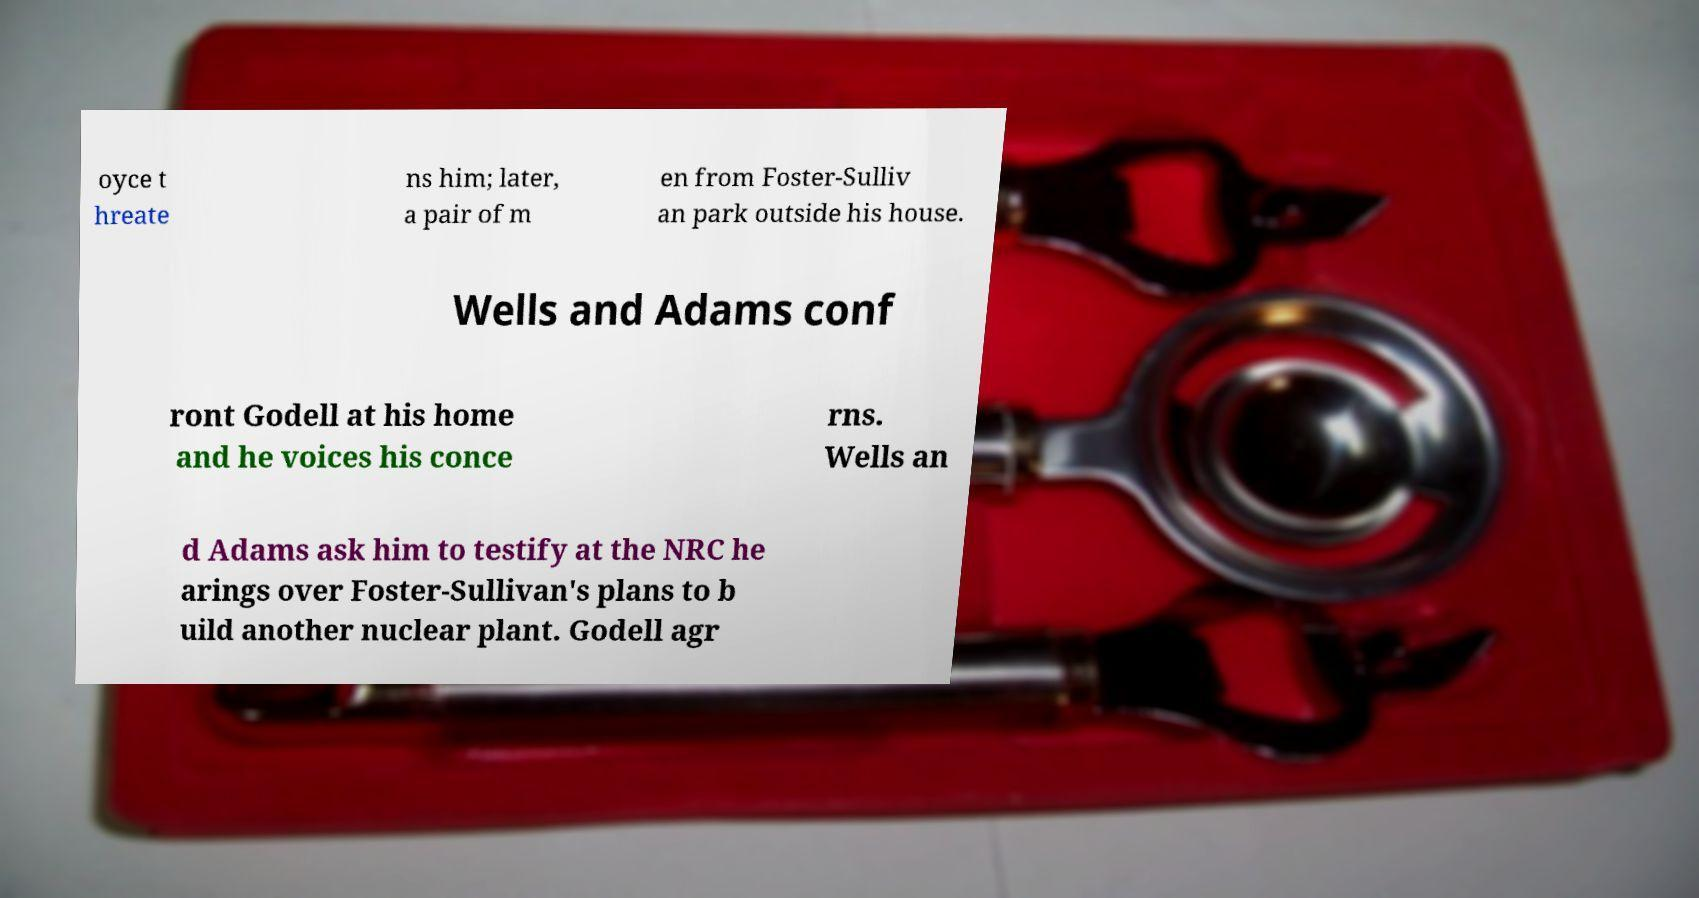What messages or text are displayed in this image? I need them in a readable, typed format. oyce t hreate ns him; later, a pair of m en from Foster-Sulliv an park outside his house. Wells and Adams conf ront Godell at his home and he voices his conce rns. Wells an d Adams ask him to testify at the NRC he arings over Foster-Sullivan's plans to b uild another nuclear plant. Godell agr 